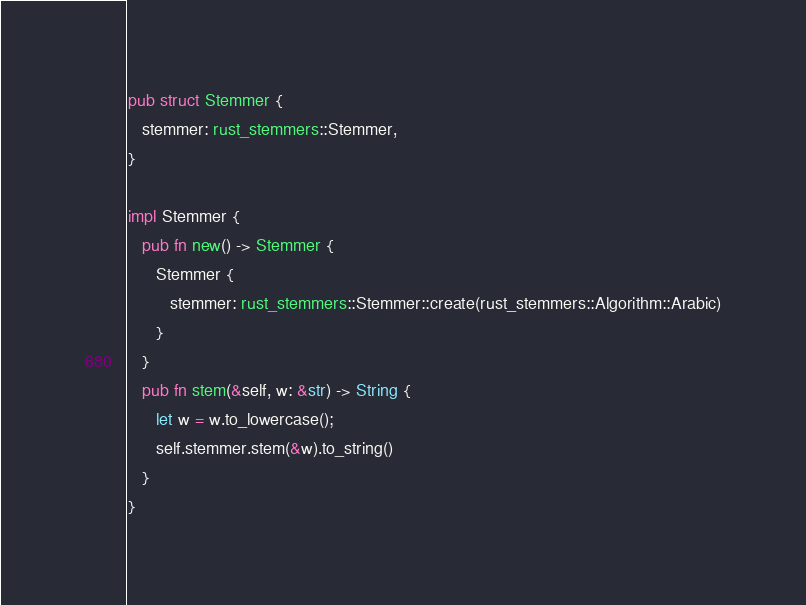Convert code to text. <code><loc_0><loc_0><loc_500><loc_500><_Rust_>
pub struct Stemmer {
   stemmer: rust_stemmers::Stemmer,
}

impl Stemmer {
   pub fn new() -> Stemmer {
      Stemmer {
         stemmer: rust_stemmers::Stemmer::create(rust_stemmers::Algorithm::Arabic)
      }
   }
   pub fn stem(&self, w: &str) -> String {
      let w = w.to_lowercase();
      self.stemmer.stem(&w).to_string()
   }
}
</code> 